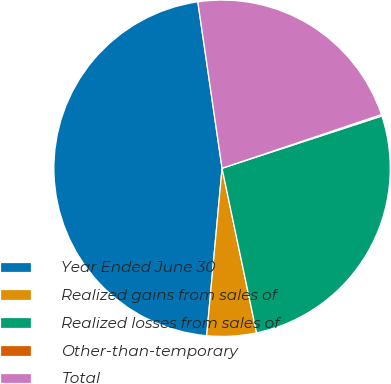<chart> <loc_0><loc_0><loc_500><loc_500><pie_chart><fcel>Year Ended June 30<fcel>Realized gains from sales of<fcel>Realized losses from sales of<fcel>Other-than-temporary<fcel>Total<nl><fcel>46.24%<fcel>4.75%<fcel>26.74%<fcel>0.14%<fcel>22.13%<nl></chart> 